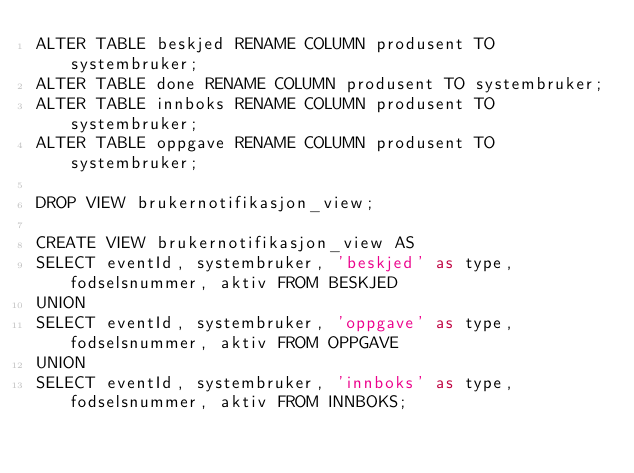<code> <loc_0><loc_0><loc_500><loc_500><_SQL_>ALTER TABLE beskjed RENAME COLUMN produsent TO systembruker;
ALTER TABLE done RENAME COLUMN produsent TO systembruker;
ALTER TABLE innboks RENAME COLUMN produsent TO systembruker;
ALTER TABLE oppgave RENAME COLUMN produsent TO systembruker;

DROP VIEW brukernotifikasjon_view;

CREATE VIEW brukernotifikasjon_view AS
SELECT eventId, systembruker, 'beskjed' as type, fodselsnummer, aktiv FROM BESKJED
UNION
SELECT eventId, systembruker, 'oppgave' as type, fodselsnummer, aktiv FROM OPPGAVE
UNION
SELECT eventId, systembruker, 'innboks' as type, fodselsnummer, aktiv FROM INNBOKS;
</code> 